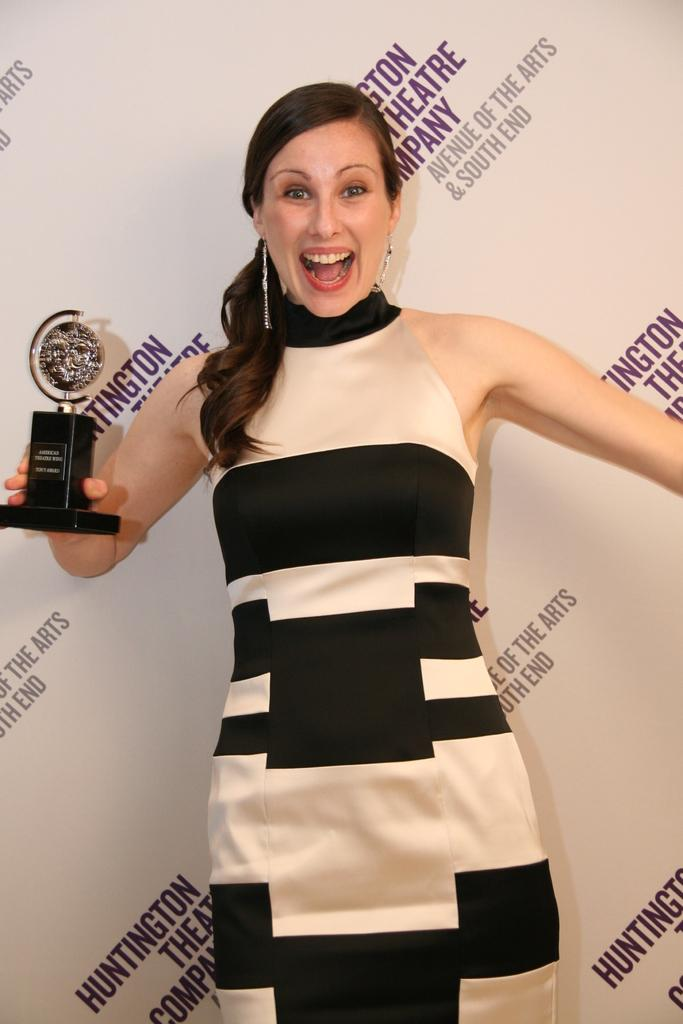<image>
Share a concise interpretation of the image provided. a woman with an American Theater Wing Tony Award in her hand 